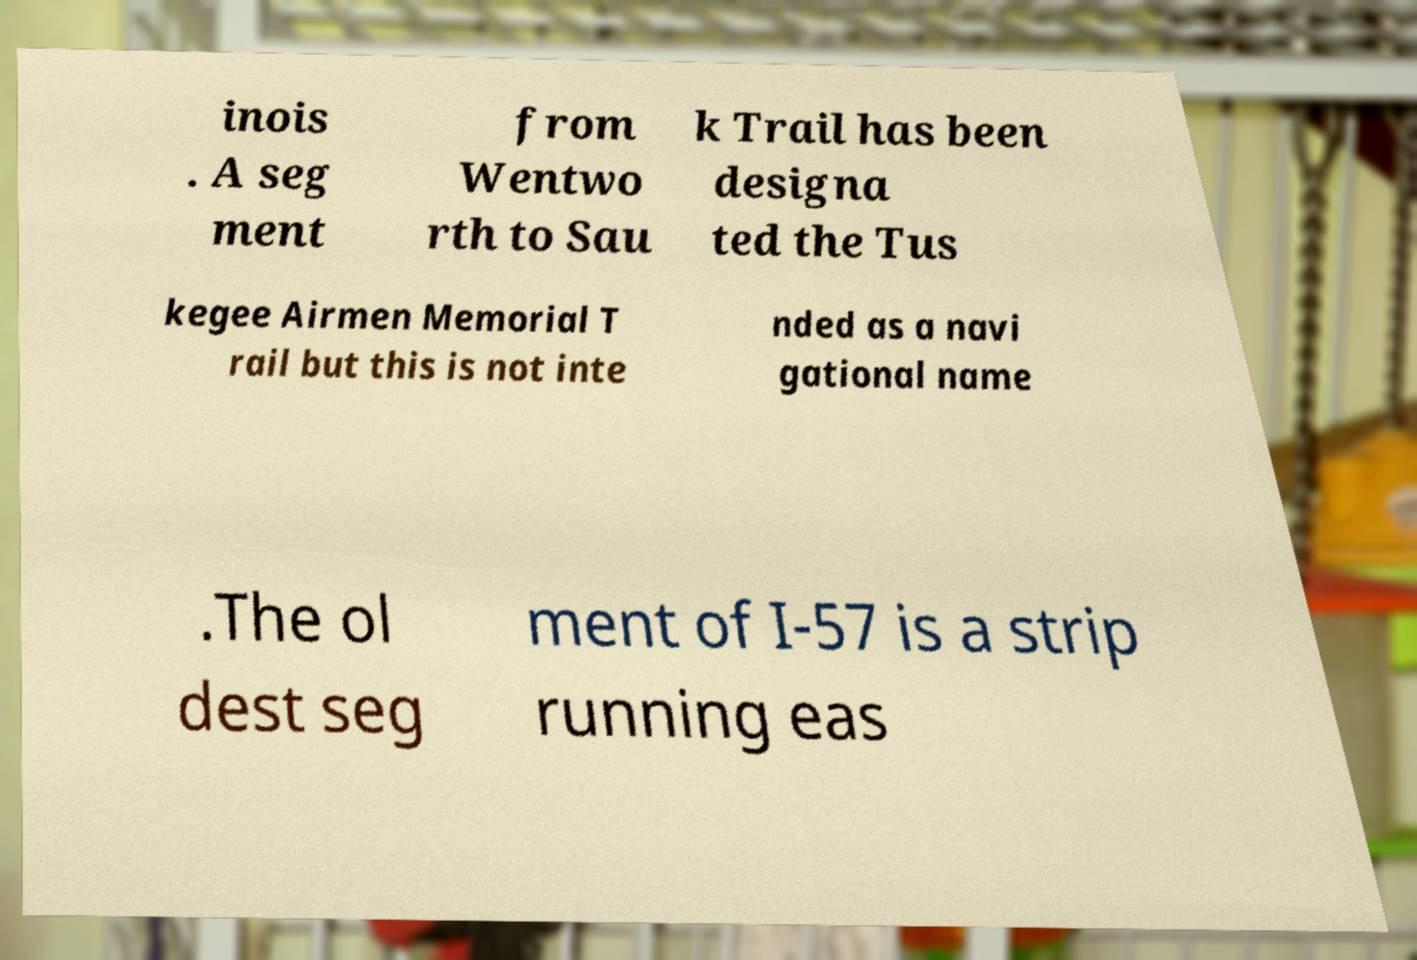Could you extract and type out the text from this image? inois . A seg ment from Wentwo rth to Sau k Trail has been designa ted the Tus kegee Airmen Memorial T rail but this is not inte nded as a navi gational name .The ol dest seg ment of I-57 is a strip running eas 